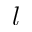<formula> <loc_0><loc_0><loc_500><loc_500>l</formula> 